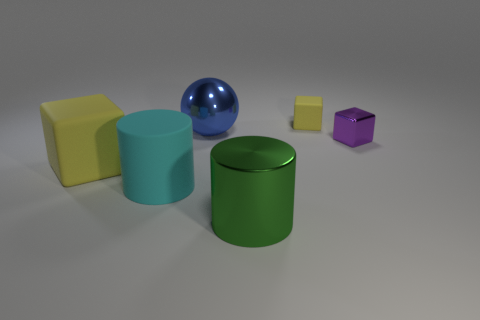Add 1 big shiny cylinders. How many objects exist? 7 Subtract all balls. How many objects are left? 5 Add 4 big cubes. How many big cubes are left? 5 Add 1 tiny gray balls. How many tiny gray balls exist? 1 Subtract 1 cyan cylinders. How many objects are left? 5 Subtract all cyan cylinders. Subtract all cyan matte spheres. How many objects are left? 5 